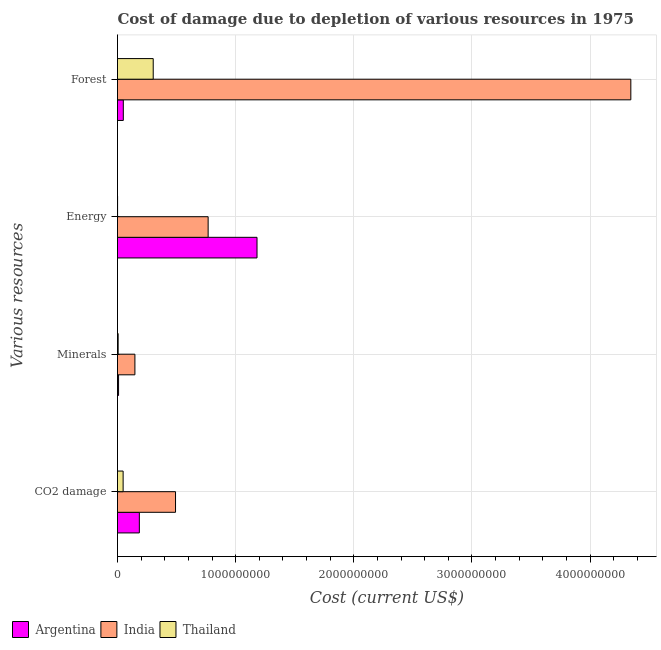Are the number of bars per tick equal to the number of legend labels?
Offer a terse response. Yes. How many bars are there on the 2nd tick from the bottom?
Provide a short and direct response. 3. What is the label of the 3rd group of bars from the top?
Keep it short and to the point. Minerals. What is the cost of damage due to depletion of forests in India?
Your response must be concise. 4.35e+09. Across all countries, what is the maximum cost of damage due to depletion of coal?
Your response must be concise. 4.91e+08. Across all countries, what is the minimum cost of damage due to depletion of energy?
Provide a succinct answer. 6.64e+05. In which country was the cost of damage due to depletion of coal minimum?
Offer a terse response. Thailand. What is the total cost of damage due to depletion of forests in the graph?
Your response must be concise. 4.70e+09. What is the difference between the cost of damage due to depletion of coal in Thailand and that in Argentina?
Give a very brief answer. -1.37e+08. What is the difference between the cost of damage due to depletion of forests in Thailand and the cost of damage due to depletion of energy in Argentina?
Offer a very short reply. -8.79e+08. What is the average cost of damage due to depletion of forests per country?
Ensure brevity in your answer.  1.57e+09. What is the difference between the cost of damage due to depletion of minerals and cost of damage due to depletion of energy in Argentina?
Your answer should be very brief. -1.17e+09. In how many countries, is the cost of damage due to depletion of minerals greater than 600000000 US$?
Offer a very short reply. 0. What is the ratio of the cost of damage due to depletion of minerals in Thailand to that in Argentina?
Your answer should be very brief. 0.62. Is the cost of damage due to depletion of energy in Argentina less than that in India?
Offer a very short reply. No. What is the difference between the highest and the second highest cost of damage due to depletion of minerals?
Ensure brevity in your answer.  1.38e+08. What is the difference between the highest and the lowest cost of damage due to depletion of energy?
Your answer should be very brief. 1.18e+09. Is the sum of the cost of damage due to depletion of forests in Thailand and India greater than the maximum cost of damage due to depletion of minerals across all countries?
Your answer should be compact. Yes. Is it the case that in every country, the sum of the cost of damage due to depletion of minerals and cost of damage due to depletion of coal is greater than the sum of cost of damage due to depletion of energy and cost of damage due to depletion of forests?
Make the answer very short. No. What does the 1st bar from the top in Energy represents?
Provide a short and direct response. Thailand. What does the 3rd bar from the bottom in CO2 damage represents?
Provide a short and direct response. Thailand. Is it the case that in every country, the sum of the cost of damage due to depletion of coal and cost of damage due to depletion of minerals is greater than the cost of damage due to depletion of energy?
Your response must be concise. No. What is the difference between two consecutive major ticks on the X-axis?
Provide a succinct answer. 1.00e+09. Does the graph contain any zero values?
Make the answer very short. No. Where does the legend appear in the graph?
Your answer should be very brief. Bottom left. How many legend labels are there?
Offer a terse response. 3. How are the legend labels stacked?
Your answer should be very brief. Horizontal. What is the title of the graph?
Provide a short and direct response. Cost of damage due to depletion of various resources in 1975 . What is the label or title of the X-axis?
Offer a terse response. Cost (current US$). What is the label or title of the Y-axis?
Give a very brief answer. Various resources. What is the Cost (current US$) in Argentina in CO2 damage?
Ensure brevity in your answer.  1.85e+08. What is the Cost (current US$) in India in CO2 damage?
Your answer should be very brief. 4.91e+08. What is the Cost (current US$) in Thailand in CO2 damage?
Your answer should be very brief. 4.75e+07. What is the Cost (current US$) in Argentina in Minerals?
Your answer should be compact. 8.94e+06. What is the Cost (current US$) in India in Minerals?
Your answer should be very brief. 1.47e+08. What is the Cost (current US$) in Thailand in Minerals?
Your answer should be compact. 5.57e+06. What is the Cost (current US$) of Argentina in Energy?
Your answer should be very brief. 1.18e+09. What is the Cost (current US$) of India in Energy?
Your answer should be compact. 7.67e+08. What is the Cost (current US$) in Thailand in Energy?
Make the answer very short. 6.64e+05. What is the Cost (current US$) in Argentina in Forest?
Make the answer very short. 4.92e+07. What is the Cost (current US$) in India in Forest?
Offer a terse response. 4.35e+09. What is the Cost (current US$) of Thailand in Forest?
Ensure brevity in your answer.  3.02e+08. Across all Various resources, what is the maximum Cost (current US$) in Argentina?
Offer a terse response. 1.18e+09. Across all Various resources, what is the maximum Cost (current US$) in India?
Provide a succinct answer. 4.35e+09. Across all Various resources, what is the maximum Cost (current US$) of Thailand?
Your answer should be compact. 3.02e+08. Across all Various resources, what is the minimum Cost (current US$) in Argentina?
Provide a succinct answer. 8.94e+06. Across all Various resources, what is the minimum Cost (current US$) of India?
Your response must be concise. 1.47e+08. Across all Various resources, what is the minimum Cost (current US$) of Thailand?
Your answer should be very brief. 6.64e+05. What is the total Cost (current US$) of Argentina in the graph?
Offer a very short reply. 1.42e+09. What is the total Cost (current US$) of India in the graph?
Offer a very short reply. 5.75e+09. What is the total Cost (current US$) in Thailand in the graph?
Keep it short and to the point. 3.56e+08. What is the difference between the Cost (current US$) of Argentina in CO2 damage and that in Minerals?
Offer a very short reply. 1.76e+08. What is the difference between the Cost (current US$) of India in CO2 damage and that in Minerals?
Your answer should be compact. 3.44e+08. What is the difference between the Cost (current US$) of Thailand in CO2 damage and that in Minerals?
Your answer should be very brief. 4.20e+07. What is the difference between the Cost (current US$) in Argentina in CO2 damage and that in Energy?
Keep it short and to the point. -9.96e+08. What is the difference between the Cost (current US$) in India in CO2 damage and that in Energy?
Keep it short and to the point. -2.76e+08. What is the difference between the Cost (current US$) in Thailand in CO2 damage and that in Energy?
Offer a very short reply. 4.69e+07. What is the difference between the Cost (current US$) of Argentina in CO2 damage and that in Forest?
Offer a terse response. 1.36e+08. What is the difference between the Cost (current US$) in India in CO2 damage and that in Forest?
Give a very brief answer. -3.85e+09. What is the difference between the Cost (current US$) of Thailand in CO2 damage and that in Forest?
Your answer should be very brief. -2.55e+08. What is the difference between the Cost (current US$) in Argentina in Minerals and that in Energy?
Offer a very short reply. -1.17e+09. What is the difference between the Cost (current US$) of India in Minerals and that in Energy?
Offer a very short reply. -6.20e+08. What is the difference between the Cost (current US$) in Thailand in Minerals and that in Energy?
Provide a short and direct response. 4.91e+06. What is the difference between the Cost (current US$) in Argentina in Minerals and that in Forest?
Ensure brevity in your answer.  -4.03e+07. What is the difference between the Cost (current US$) in India in Minerals and that in Forest?
Make the answer very short. -4.20e+09. What is the difference between the Cost (current US$) of Thailand in Minerals and that in Forest?
Your answer should be compact. -2.97e+08. What is the difference between the Cost (current US$) in Argentina in Energy and that in Forest?
Provide a short and direct response. 1.13e+09. What is the difference between the Cost (current US$) of India in Energy and that in Forest?
Give a very brief answer. -3.58e+09. What is the difference between the Cost (current US$) of Thailand in Energy and that in Forest?
Offer a terse response. -3.02e+08. What is the difference between the Cost (current US$) in Argentina in CO2 damage and the Cost (current US$) in India in Minerals?
Ensure brevity in your answer.  3.75e+07. What is the difference between the Cost (current US$) in Argentina in CO2 damage and the Cost (current US$) in Thailand in Minerals?
Keep it short and to the point. 1.79e+08. What is the difference between the Cost (current US$) in India in CO2 damage and the Cost (current US$) in Thailand in Minerals?
Your answer should be very brief. 4.86e+08. What is the difference between the Cost (current US$) in Argentina in CO2 damage and the Cost (current US$) in India in Energy?
Give a very brief answer. -5.82e+08. What is the difference between the Cost (current US$) in Argentina in CO2 damage and the Cost (current US$) in Thailand in Energy?
Offer a terse response. 1.84e+08. What is the difference between the Cost (current US$) in India in CO2 damage and the Cost (current US$) in Thailand in Energy?
Offer a terse response. 4.91e+08. What is the difference between the Cost (current US$) in Argentina in CO2 damage and the Cost (current US$) in India in Forest?
Your answer should be very brief. -4.16e+09. What is the difference between the Cost (current US$) of Argentina in CO2 damage and the Cost (current US$) of Thailand in Forest?
Your answer should be very brief. -1.17e+08. What is the difference between the Cost (current US$) in India in CO2 damage and the Cost (current US$) in Thailand in Forest?
Offer a very short reply. 1.89e+08. What is the difference between the Cost (current US$) of Argentina in Minerals and the Cost (current US$) of India in Energy?
Ensure brevity in your answer.  -7.58e+08. What is the difference between the Cost (current US$) of Argentina in Minerals and the Cost (current US$) of Thailand in Energy?
Make the answer very short. 8.27e+06. What is the difference between the Cost (current US$) in India in Minerals and the Cost (current US$) in Thailand in Energy?
Your answer should be compact. 1.47e+08. What is the difference between the Cost (current US$) in Argentina in Minerals and the Cost (current US$) in India in Forest?
Offer a very short reply. -4.34e+09. What is the difference between the Cost (current US$) in Argentina in Minerals and the Cost (current US$) in Thailand in Forest?
Offer a very short reply. -2.93e+08. What is the difference between the Cost (current US$) of India in Minerals and the Cost (current US$) of Thailand in Forest?
Give a very brief answer. -1.55e+08. What is the difference between the Cost (current US$) of Argentina in Energy and the Cost (current US$) of India in Forest?
Keep it short and to the point. -3.16e+09. What is the difference between the Cost (current US$) of Argentina in Energy and the Cost (current US$) of Thailand in Forest?
Offer a terse response. 8.79e+08. What is the difference between the Cost (current US$) of India in Energy and the Cost (current US$) of Thailand in Forest?
Keep it short and to the point. 4.65e+08. What is the average Cost (current US$) in Argentina per Various resources?
Give a very brief answer. 3.56e+08. What is the average Cost (current US$) of India per Various resources?
Keep it short and to the point. 1.44e+09. What is the average Cost (current US$) of Thailand per Various resources?
Offer a very short reply. 8.90e+07. What is the difference between the Cost (current US$) in Argentina and Cost (current US$) in India in CO2 damage?
Offer a terse response. -3.06e+08. What is the difference between the Cost (current US$) in Argentina and Cost (current US$) in Thailand in CO2 damage?
Your answer should be compact. 1.37e+08. What is the difference between the Cost (current US$) of India and Cost (current US$) of Thailand in CO2 damage?
Offer a terse response. 4.44e+08. What is the difference between the Cost (current US$) in Argentina and Cost (current US$) in India in Minerals?
Ensure brevity in your answer.  -1.38e+08. What is the difference between the Cost (current US$) in Argentina and Cost (current US$) in Thailand in Minerals?
Provide a short and direct response. 3.36e+06. What is the difference between the Cost (current US$) in India and Cost (current US$) in Thailand in Minerals?
Your response must be concise. 1.42e+08. What is the difference between the Cost (current US$) in Argentina and Cost (current US$) in India in Energy?
Make the answer very short. 4.14e+08. What is the difference between the Cost (current US$) in Argentina and Cost (current US$) in Thailand in Energy?
Keep it short and to the point. 1.18e+09. What is the difference between the Cost (current US$) in India and Cost (current US$) in Thailand in Energy?
Offer a very short reply. 7.67e+08. What is the difference between the Cost (current US$) of Argentina and Cost (current US$) of India in Forest?
Keep it short and to the point. -4.30e+09. What is the difference between the Cost (current US$) in Argentina and Cost (current US$) in Thailand in Forest?
Offer a terse response. -2.53e+08. What is the difference between the Cost (current US$) in India and Cost (current US$) in Thailand in Forest?
Ensure brevity in your answer.  4.04e+09. What is the ratio of the Cost (current US$) in Argentina in CO2 damage to that in Minerals?
Offer a terse response. 20.69. What is the ratio of the Cost (current US$) of India in CO2 damage to that in Minerals?
Ensure brevity in your answer.  3.33. What is the ratio of the Cost (current US$) in Thailand in CO2 damage to that in Minerals?
Your answer should be compact. 8.53. What is the ratio of the Cost (current US$) of Argentina in CO2 damage to that in Energy?
Your answer should be very brief. 0.16. What is the ratio of the Cost (current US$) in India in CO2 damage to that in Energy?
Your answer should be very brief. 0.64. What is the ratio of the Cost (current US$) of Thailand in CO2 damage to that in Energy?
Make the answer very short. 71.55. What is the ratio of the Cost (current US$) of Argentina in CO2 damage to that in Forest?
Your answer should be very brief. 3.76. What is the ratio of the Cost (current US$) in India in CO2 damage to that in Forest?
Offer a terse response. 0.11. What is the ratio of the Cost (current US$) of Thailand in CO2 damage to that in Forest?
Your response must be concise. 0.16. What is the ratio of the Cost (current US$) of Argentina in Minerals to that in Energy?
Give a very brief answer. 0.01. What is the ratio of the Cost (current US$) of India in Minerals to that in Energy?
Provide a succinct answer. 0.19. What is the ratio of the Cost (current US$) in Thailand in Minerals to that in Energy?
Provide a succinct answer. 8.38. What is the ratio of the Cost (current US$) of Argentina in Minerals to that in Forest?
Provide a short and direct response. 0.18. What is the ratio of the Cost (current US$) of India in Minerals to that in Forest?
Give a very brief answer. 0.03. What is the ratio of the Cost (current US$) in Thailand in Minerals to that in Forest?
Your answer should be very brief. 0.02. What is the ratio of the Cost (current US$) of Argentina in Energy to that in Forest?
Your response must be concise. 24. What is the ratio of the Cost (current US$) of India in Energy to that in Forest?
Make the answer very short. 0.18. What is the ratio of the Cost (current US$) of Thailand in Energy to that in Forest?
Your answer should be compact. 0. What is the difference between the highest and the second highest Cost (current US$) of Argentina?
Make the answer very short. 9.96e+08. What is the difference between the highest and the second highest Cost (current US$) in India?
Offer a terse response. 3.58e+09. What is the difference between the highest and the second highest Cost (current US$) of Thailand?
Your answer should be very brief. 2.55e+08. What is the difference between the highest and the lowest Cost (current US$) in Argentina?
Keep it short and to the point. 1.17e+09. What is the difference between the highest and the lowest Cost (current US$) in India?
Give a very brief answer. 4.20e+09. What is the difference between the highest and the lowest Cost (current US$) of Thailand?
Give a very brief answer. 3.02e+08. 